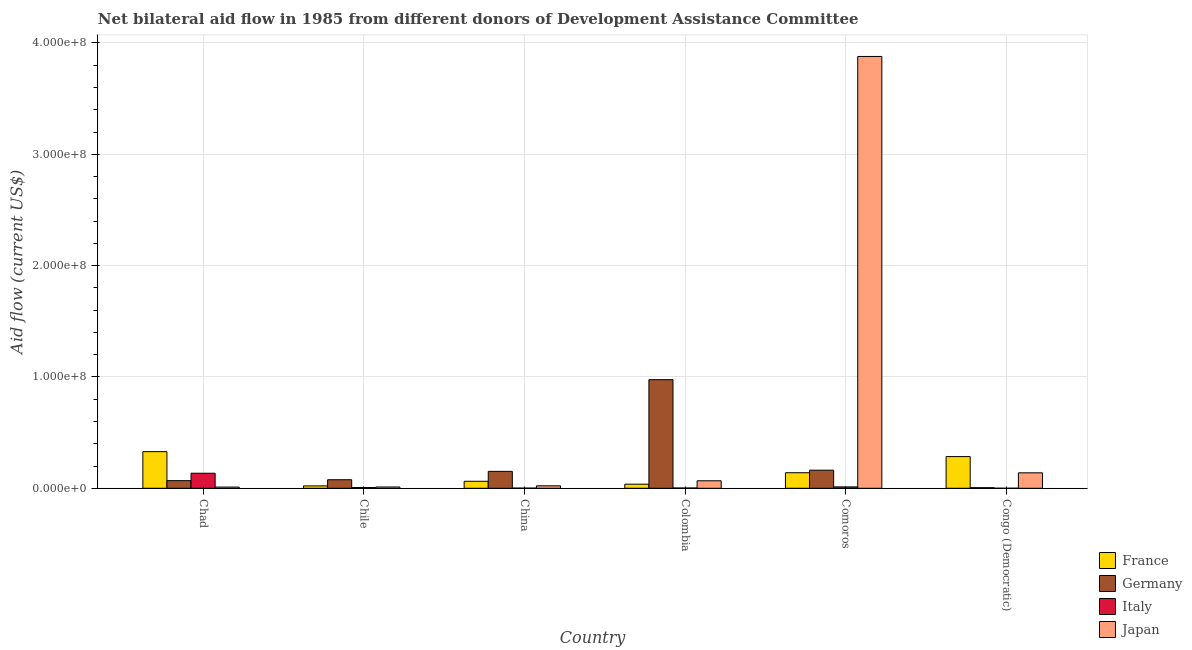How many different coloured bars are there?
Offer a terse response. 4. How many bars are there on the 4th tick from the left?
Make the answer very short. 4. What is the amount of aid given by germany in Chile?
Provide a short and direct response. 7.68e+06. Across all countries, what is the maximum amount of aid given by japan?
Give a very brief answer. 3.88e+08. Across all countries, what is the minimum amount of aid given by france?
Your answer should be very brief. 2.15e+06. In which country was the amount of aid given by italy maximum?
Make the answer very short. Chad. In which country was the amount of aid given by japan minimum?
Make the answer very short. Chad. What is the total amount of aid given by france in the graph?
Your answer should be very brief. 8.75e+07. What is the difference between the amount of aid given by germany in Chile and that in China?
Provide a succinct answer. -7.52e+06. What is the difference between the amount of aid given by japan in Chad and the amount of aid given by germany in Congo (Democratic)?
Keep it short and to the point. 5.40e+05. What is the average amount of aid given by germany per country?
Provide a succinct answer. 2.40e+07. What is the difference between the amount of aid given by france and amount of aid given by germany in China?
Your response must be concise. -8.90e+06. In how many countries, is the amount of aid given by germany greater than 220000000 US$?
Offer a very short reply. 0. What is the ratio of the amount of aid given by japan in Colombia to that in Congo (Democratic)?
Your answer should be very brief. 0.48. Is the amount of aid given by germany in China less than that in Congo (Democratic)?
Your response must be concise. No. What is the difference between the highest and the second highest amount of aid given by japan?
Give a very brief answer. 3.74e+08. What is the difference between the highest and the lowest amount of aid given by france?
Your answer should be very brief. 3.08e+07. What does the 4th bar from the left in Colombia represents?
Keep it short and to the point. Japan. What does the 2nd bar from the right in Chile represents?
Make the answer very short. Italy. Is it the case that in every country, the sum of the amount of aid given by france and amount of aid given by germany is greater than the amount of aid given by italy?
Your answer should be very brief. Yes. How many countries are there in the graph?
Make the answer very short. 6. Are the values on the major ticks of Y-axis written in scientific E-notation?
Your answer should be very brief. Yes. Does the graph contain grids?
Your answer should be very brief. Yes. Where does the legend appear in the graph?
Your answer should be very brief. Bottom right. How are the legend labels stacked?
Make the answer very short. Vertical. What is the title of the graph?
Make the answer very short. Net bilateral aid flow in 1985 from different donors of Development Assistance Committee. What is the Aid flow (current US$) in France in Chad?
Ensure brevity in your answer.  3.29e+07. What is the Aid flow (current US$) of Germany in Chad?
Offer a terse response. 6.84e+06. What is the Aid flow (current US$) of Italy in Chad?
Offer a very short reply. 1.35e+07. What is the Aid flow (current US$) of Japan in Chad?
Keep it short and to the point. 1.07e+06. What is the Aid flow (current US$) of France in Chile?
Offer a very short reply. 2.15e+06. What is the Aid flow (current US$) in Germany in Chile?
Your response must be concise. 7.68e+06. What is the Aid flow (current US$) in Italy in Chile?
Offer a terse response. 6.70e+05. What is the Aid flow (current US$) in Japan in Chile?
Your response must be concise. 1.16e+06. What is the Aid flow (current US$) in France in China?
Your answer should be compact. 6.30e+06. What is the Aid flow (current US$) in Germany in China?
Keep it short and to the point. 1.52e+07. What is the Aid flow (current US$) in Japan in China?
Make the answer very short. 2.21e+06. What is the Aid flow (current US$) in France in Colombia?
Your answer should be compact. 3.68e+06. What is the Aid flow (current US$) in Germany in Colombia?
Keep it short and to the point. 9.76e+07. What is the Aid flow (current US$) of Japan in Colombia?
Ensure brevity in your answer.  6.73e+06. What is the Aid flow (current US$) in France in Comoros?
Keep it short and to the point. 1.40e+07. What is the Aid flow (current US$) of Germany in Comoros?
Give a very brief answer. 1.62e+07. What is the Aid flow (current US$) in Italy in Comoros?
Ensure brevity in your answer.  1.24e+06. What is the Aid flow (current US$) of Japan in Comoros?
Your answer should be very brief. 3.88e+08. What is the Aid flow (current US$) in France in Congo (Democratic)?
Provide a short and direct response. 2.85e+07. What is the Aid flow (current US$) of Germany in Congo (Democratic)?
Offer a very short reply. 5.30e+05. What is the Aid flow (current US$) of Italy in Congo (Democratic)?
Your answer should be very brief. 4.00e+04. What is the Aid flow (current US$) of Japan in Congo (Democratic)?
Keep it short and to the point. 1.39e+07. Across all countries, what is the maximum Aid flow (current US$) of France?
Make the answer very short. 3.29e+07. Across all countries, what is the maximum Aid flow (current US$) of Germany?
Your answer should be compact. 9.76e+07. Across all countries, what is the maximum Aid flow (current US$) in Italy?
Make the answer very short. 1.35e+07. Across all countries, what is the maximum Aid flow (current US$) in Japan?
Provide a short and direct response. 3.88e+08. Across all countries, what is the minimum Aid flow (current US$) in France?
Provide a short and direct response. 2.15e+06. Across all countries, what is the minimum Aid flow (current US$) in Germany?
Offer a terse response. 5.30e+05. Across all countries, what is the minimum Aid flow (current US$) in Italy?
Offer a very short reply. 4.00e+04. Across all countries, what is the minimum Aid flow (current US$) of Japan?
Give a very brief answer. 1.07e+06. What is the total Aid flow (current US$) in France in the graph?
Make the answer very short. 8.75e+07. What is the total Aid flow (current US$) in Germany in the graph?
Provide a short and direct response. 1.44e+08. What is the total Aid flow (current US$) in Italy in the graph?
Offer a terse response. 1.59e+07. What is the total Aid flow (current US$) of Japan in the graph?
Provide a short and direct response. 4.13e+08. What is the difference between the Aid flow (current US$) in France in Chad and that in Chile?
Your answer should be very brief. 3.08e+07. What is the difference between the Aid flow (current US$) of Germany in Chad and that in Chile?
Offer a terse response. -8.40e+05. What is the difference between the Aid flow (current US$) of Italy in Chad and that in Chile?
Ensure brevity in your answer.  1.28e+07. What is the difference between the Aid flow (current US$) of Japan in Chad and that in Chile?
Your answer should be very brief. -9.00e+04. What is the difference between the Aid flow (current US$) in France in Chad and that in China?
Keep it short and to the point. 2.66e+07. What is the difference between the Aid flow (current US$) in Germany in Chad and that in China?
Your response must be concise. -8.36e+06. What is the difference between the Aid flow (current US$) of Italy in Chad and that in China?
Offer a terse response. 1.34e+07. What is the difference between the Aid flow (current US$) in Japan in Chad and that in China?
Your response must be concise. -1.14e+06. What is the difference between the Aid flow (current US$) in France in Chad and that in Colombia?
Your answer should be very brief. 2.92e+07. What is the difference between the Aid flow (current US$) of Germany in Chad and that in Colombia?
Provide a succinct answer. -9.07e+07. What is the difference between the Aid flow (current US$) in Italy in Chad and that in Colombia?
Your answer should be very brief. 1.32e+07. What is the difference between the Aid flow (current US$) in Japan in Chad and that in Colombia?
Keep it short and to the point. -5.66e+06. What is the difference between the Aid flow (current US$) in France in Chad and that in Comoros?
Offer a very short reply. 1.89e+07. What is the difference between the Aid flow (current US$) of Germany in Chad and that in Comoros?
Your answer should be compact. -9.40e+06. What is the difference between the Aid flow (current US$) of Italy in Chad and that in Comoros?
Make the answer very short. 1.23e+07. What is the difference between the Aid flow (current US$) of Japan in Chad and that in Comoros?
Your answer should be compact. -3.87e+08. What is the difference between the Aid flow (current US$) in France in Chad and that in Congo (Democratic)?
Make the answer very short. 4.43e+06. What is the difference between the Aid flow (current US$) of Germany in Chad and that in Congo (Democratic)?
Your answer should be very brief. 6.31e+06. What is the difference between the Aid flow (current US$) in Italy in Chad and that in Congo (Democratic)?
Provide a succinct answer. 1.35e+07. What is the difference between the Aid flow (current US$) of Japan in Chad and that in Congo (Democratic)?
Give a very brief answer. -1.28e+07. What is the difference between the Aid flow (current US$) of France in Chile and that in China?
Your answer should be very brief. -4.15e+06. What is the difference between the Aid flow (current US$) in Germany in Chile and that in China?
Your answer should be compact. -7.52e+06. What is the difference between the Aid flow (current US$) in Italy in Chile and that in China?
Your response must be concise. 5.30e+05. What is the difference between the Aid flow (current US$) in Japan in Chile and that in China?
Offer a very short reply. -1.05e+06. What is the difference between the Aid flow (current US$) of France in Chile and that in Colombia?
Provide a succinct answer. -1.53e+06. What is the difference between the Aid flow (current US$) of Germany in Chile and that in Colombia?
Provide a short and direct response. -8.99e+07. What is the difference between the Aid flow (current US$) of Japan in Chile and that in Colombia?
Offer a very short reply. -5.57e+06. What is the difference between the Aid flow (current US$) of France in Chile and that in Comoros?
Provide a succinct answer. -1.18e+07. What is the difference between the Aid flow (current US$) of Germany in Chile and that in Comoros?
Provide a succinct answer. -8.56e+06. What is the difference between the Aid flow (current US$) in Italy in Chile and that in Comoros?
Your answer should be compact. -5.70e+05. What is the difference between the Aid flow (current US$) in Japan in Chile and that in Comoros?
Your answer should be compact. -3.87e+08. What is the difference between the Aid flow (current US$) in France in Chile and that in Congo (Democratic)?
Your response must be concise. -2.63e+07. What is the difference between the Aid flow (current US$) in Germany in Chile and that in Congo (Democratic)?
Provide a succinct answer. 7.15e+06. What is the difference between the Aid flow (current US$) of Italy in Chile and that in Congo (Democratic)?
Offer a very short reply. 6.30e+05. What is the difference between the Aid flow (current US$) in Japan in Chile and that in Congo (Democratic)?
Your answer should be very brief. -1.27e+07. What is the difference between the Aid flow (current US$) in France in China and that in Colombia?
Provide a succinct answer. 2.62e+06. What is the difference between the Aid flow (current US$) of Germany in China and that in Colombia?
Offer a very short reply. -8.24e+07. What is the difference between the Aid flow (current US$) of Japan in China and that in Colombia?
Keep it short and to the point. -4.52e+06. What is the difference between the Aid flow (current US$) in France in China and that in Comoros?
Provide a short and direct response. -7.67e+06. What is the difference between the Aid flow (current US$) of Germany in China and that in Comoros?
Offer a very short reply. -1.04e+06. What is the difference between the Aid flow (current US$) of Italy in China and that in Comoros?
Make the answer very short. -1.10e+06. What is the difference between the Aid flow (current US$) of Japan in China and that in Comoros?
Offer a very short reply. -3.86e+08. What is the difference between the Aid flow (current US$) in France in China and that in Congo (Democratic)?
Offer a terse response. -2.22e+07. What is the difference between the Aid flow (current US$) of Germany in China and that in Congo (Democratic)?
Provide a short and direct response. 1.47e+07. What is the difference between the Aid flow (current US$) in Japan in China and that in Congo (Democratic)?
Provide a succinct answer. -1.17e+07. What is the difference between the Aid flow (current US$) of France in Colombia and that in Comoros?
Keep it short and to the point. -1.03e+07. What is the difference between the Aid flow (current US$) in Germany in Colombia and that in Comoros?
Your answer should be compact. 8.13e+07. What is the difference between the Aid flow (current US$) in Italy in Colombia and that in Comoros?
Your answer should be very brief. -9.80e+05. What is the difference between the Aid flow (current US$) of Japan in Colombia and that in Comoros?
Make the answer very short. -3.81e+08. What is the difference between the Aid flow (current US$) of France in Colombia and that in Congo (Democratic)?
Ensure brevity in your answer.  -2.48e+07. What is the difference between the Aid flow (current US$) of Germany in Colombia and that in Congo (Democratic)?
Ensure brevity in your answer.  9.70e+07. What is the difference between the Aid flow (current US$) of Italy in Colombia and that in Congo (Democratic)?
Offer a terse response. 2.20e+05. What is the difference between the Aid flow (current US$) in Japan in Colombia and that in Congo (Democratic)?
Your response must be concise. -7.16e+06. What is the difference between the Aid flow (current US$) in France in Comoros and that in Congo (Democratic)?
Your answer should be very brief. -1.45e+07. What is the difference between the Aid flow (current US$) of Germany in Comoros and that in Congo (Democratic)?
Give a very brief answer. 1.57e+07. What is the difference between the Aid flow (current US$) of Italy in Comoros and that in Congo (Democratic)?
Ensure brevity in your answer.  1.20e+06. What is the difference between the Aid flow (current US$) of Japan in Comoros and that in Congo (Democratic)?
Give a very brief answer. 3.74e+08. What is the difference between the Aid flow (current US$) in France in Chad and the Aid flow (current US$) in Germany in Chile?
Provide a short and direct response. 2.52e+07. What is the difference between the Aid flow (current US$) in France in Chad and the Aid flow (current US$) in Italy in Chile?
Give a very brief answer. 3.22e+07. What is the difference between the Aid flow (current US$) of France in Chad and the Aid flow (current US$) of Japan in Chile?
Your response must be concise. 3.17e+07. What is the difference between the Aid flow (current US$) of Germany in Chad and the Aid flow (current US$) of Italy in Chile?
Ensure brevity in your answer.  6.17e+06. What is the difference between the Aid flow (current US$) of Germany in Chad and the Aid flow (current US$) of Japan in Chile?
Provide a short and direct response. 5.68e+06. What is the difference between the Aid flow (current US$) of Italy in Chad and the Aid flow (current US$) of Japan in Chile?
Your answer should be very brief. 1.24e+07. What is the difference between the Aid flow (current US$) of France in Chad and the Aid flow (current US$) of Germany in China?
Provide a succinct answer. 1.77e+07. What is the difference between the Aid flow (current US$) in France in Chad and the Aid flow (current US$) in Italy in China?
Make the answer very short. 3.28e+07. What is the difference between the Aid flow (current US$) in France in Chad and the Aid flow (current US$) in Japan in China?
Give a very brief answer. 3.07e+07. What is the difference between the Aid flow (current US$) of Germany in Chad and the Aid flow (current US$) of Italy in China?
Offer a very short reply. 6.70e+06. What is the difference between the Aid flow (current US$) in Germany in Chad and the Aid flow (current US$) in Japan in China?
Ensure brevity in your answer.  4.63e+06. What is the difference between the Aid flow (current US$) of Italy in Chad and the Aid flow (current US$) of Japan in China?
Keep it short and to the point. 1.13e+07. What is the difference between the Aid flow (current US$) in France in Chad and the Aid flow (current US$) in Germany in Colombia?
Offer a terse response. -6.47e+07. What is the difference between the Aid flow (current US$) in France in Chad and the Aid flow (current US$) in Italy in Colombia?
Make the answer very short. 3.26e+07. What is the difference between the Aid flow (current US$) of France in Chad and the Aid flow (current US$) of Japan in Colombia?
Your answer should be very brief. 2.62e+07. What is the difference between the Aid flow (current US$) of Germany in Chad and the Aid flow (current US$) of Italy in Colombia?
Provide a succinct answer. 6.58e+06. What is the difference between the Aid flow (current US$) in Germany in Chad and the Aid flow (current US$) in Japan in Colombia?
Provide a short and direct response. 1.10e+05. What is the difference between the Aid flow (current US$) in Italy in Chad and the Aid flow (current US$) in Japan in Colombia?
Your answer should be compact. 6.78e+06. What is the difference between the Aid flow (current US$) of France in Chad and the Aid flow (current US$) of Germany in Comoros?
Provide a succinct answer. 1.67e+07. What is the difference between the Aid flow (current US$) in France in Chad and the Aid flow (current US$) in Italy in Comoros?
Your answer should be very brief. 3.17e+07. What is the difference between the Aid flow (current US$) of France in Chad and the Aid flow (current US$) of Japan in Comoros?
Keep it short and to the point. -3.55e+08. What is the difference between the Aid flow (current US$) of Germany in Chad and the Aid flow (current US$) of Italy in Comoros?
Your answer should be very brief. 5.60e+06. What is the difference between the Aid flow (current US$) of Germany in Chad and the Aid flow (current US$) of Japan in Comoros?
Provide a succinct answer. -3.81e+08. What is the difference between the Aid flow (current US$) of Italy in Chad and the Aid flow (current US$) of Japan in Comoros?
Make the answer very short. -3.74e+08. What is the difference between the Aid flow (current US$) in France in Chad and the Aid flow (current US$) in Germany in Congo (Democratic)?
Keep it short and to the point. 3.24e+07. What is the difference between the Aid flow (current US$) of France in Chad and the Aid flow (current US$) of Italy in Congo (Democratic)?
Your answer should be compact. 3.29e+07. What is the difference between the Aid flow (current US$) of France in Chad and the Aid flow (current US$) of Japan in Congo (Democratic)?
Offer a terse response. 1.90e+07. What is the difference between the Aid flow (current US$) of Germany in Chad and the Aid flow (current US$) of Italy in Congo (Democratic)?
Ensure brevity in your answer.  6.80e+06. What is the difference between the Aid flow (current US$) of Germany in Chad and the Aid flow (current US$) of Japan in Congo (Democratic)?
Ensure brevity in your answer.  -7.05e+06. What is the difference between the Aid flow (current US$) of Italy in Chad and the Aid flow (current US$) of Japan in Congo (Democratic)?
Make the answer very short. -3.80e+05. What is the difference between the Aid flow (current US$) in France in Chile and the Aid flow (current US$) in Germany in China?
Give a very brief answer. -1.30e+07. What is the difference between the Aid flow (current US$) of France in Chile and the Aid flow (current US$) of Italy in China?
Offer a very short reply. 2.01e+06. What is the difference between the Aid flow (current US$) in Germany in Chile and the Aid flow (current US$) in Italy in China?
Keep it short and to the point. 7.54e+06. What is the difference between the Aid flow (current US$) of Germany in Chile and the Aid flow (current US$) of Japan in China?
Give a very brief answer. 5.47e+06. What is the difference between the Aid flow (current US$) in Italy in Chile and the Aid flow (current US$) in Japan in China?
Provide a succinct answer. -1.54e+06. What is the difference between the Aid flow (current US$) of France in Chile and the Aid flow (current US$) of Germany in Colombia?
Make the answer very short. -9.54e+07. What is the difference between the Aid flow (current US$) of France in Chile and the Aid flow (current US$) of Italy in Colombia?
Provide a succinct answer. 1.89e+06. What is the difference between the Aid flow (current US$) in France in Chile and the Aid flow (current US$) in Japan in Colombia?
Make the answer very short. -4.58e+06. What is the difference between the Aid flow (current US$) in Germany in Chile and the Aid flow (current US$) in Italy in Colombia?
Keep it short and to the point. 7.42e+06. What is the difference between the Aid flow (current US$) in Germany in Chile and the Aid flow (current US$) in Japan in Colombia?
Make the answer very short. 9.50e+05. What is the difference between the Aid flow (current US$) in Italy in Chile and the Aid flow (current US$) in Japan in Colombia?
Make the answer very short. -6.06e+06. What is the difference between the Aid flow (current US$) of France in Chile and the Aid flow (current US$) of Germany in Comoros?
Offer a very short reply. -1.41e+07. What is the difference between the Aid flow (current US$) in France in Chile and the Aid flow (current US$) in Italy in Comoros?
Provide a short and direct response. 9.10e+05. What is the difference between the Aid flow (current US$) in France in Chile and the Aid flow (current US$) in Japan in Comoros?
Your answer should be very brief. -3.86e+08. What is the difference between the Aid flow (current US$) in Germany in Chile and the Aid flow (current US$) in Italy in Comoros?
Provide a succinct answer. 6.44e+06. What is the difference between the Aid flow (current US$) in Germany in Chile and the Aid flow (current US$) in Japan in Comoros?
Your answer should be compact. -3.80e+08. What is the difference between the Aid flow (current US$) in Italy in Chile and the Aid flow (current US$) in Japan in Comoros?
Make the answer very short. -3.87e+08. What is the difference between the Aid flow (current US$) of France in Chile and the Aid flow (current US$) of Germany in Congo (Democratic)?
Your answer should be compact. 1.62e+06. What is the difference between the Aid flow (current US$) of France in Chile and the Aid flow (current US$) of Italy in Congo (Democratic)?
Keep it short and to the point. 2.11e+06. What is the difference between the Aid flow (current US$) in France in Chile and the Aid flow (current US$) in Japan in Congo (Democratic)?
Keep it short and to the point. -1.17e+07. What is the difference between the Aid flow (current US$) in Germany in Chile and the Aid flow (current US$) in Italy in Congo (Democratic)?
Give a very brief answer. 7.64e+06. What is the difference between the Aid flow (current US$) in Germany in Chile and the Aid flow (current US$) in Japan in Congo (Democratic)?
Provide a succinct answer. -6.21e+06. What is the difference between the Aid flow (current US$) in Italy in Chile and the Aid flow (current US$) in Japan in Congo (Democratic)?
Offer a terse response. -1.32e+07. What is the difference between the Aid flow (current US$) of France in China and the Aid flow (current US$) of Germany in Colombia?
Your answer should be very brief. -9.13e+07. What is the difference between the Aid flow (current US$) of France in China and the Aid flow (current US$) of Italy in Colombia?
Provide a short and direct response. 6.04e+06. What is the difference between the Aid flow (current US$) in France in China and the Aid flow (current US$) in Japan in Colombia?
Your answer should be very brief. -4.30e+05. What is the difference between the Aid flow (current US$) of Germany in China and the Aid flow (current US$) of Italy in Colombia?
Give a very brief answer. 1.49e+07. What is the difference between the Aid flow (current US$) of Germany in China and the Aid flow (current US$) of Japan in Colombia?
Make the answer very short. 8.47e+06. What is the difference between the Aid flow (current US$) in Italy in China and the Aid flow (current US$) in Japan in Colombia?
Give a very brief answer. -6.59e+06. What is the difference between the Aid flow (current US$) in France in China and the Aid flow (current US$) in Germany in Comoros?
Your response must be concise. -9.94e+06. What is the difference between the Aid flow (current US$) in France in China and the Aid flow (current US$) in Italy in Comoros?
Offer a terse response. 5.06e+06. What is the difference between the Aid flow (current US$) of France in China and the Aid flow (current US$) of Japan in Comoros?
Offer a terse response. -3.82e+08. What is the difference between the Aid flow (current US$) in Germany in China and the Aid flow (current US$) in Italy in Comoros?
Your answer should be very brief. 1.40e+07. What is the difference between the Aid flow (current US$) in Germany in China and the Aid flow (current US$) in Japan in Comoros?
Keep it short and to the point. -3.73e+08. What is the difference between the Aid flow (current US$) of Italy in China and the Aid flow (current US$) of Japan in Comoros?
Provide a succinct answer. -3.88e+08. What is the difference between the Aid flow (current US$) of France in China and the Aid flow (current US$) of Germany in Congo (Democratic)?
Your response must be concise. 5.77e+06. What is the difference between the Aid flow (current US$) of France in China and the Aid flow (current US$) of Italy in Congo (Democratic)?
Provide a short and direct response. 6.26e+06. What is the difference between the Aid flow (current US$) of France in China and the Aid flow (current US$) of Japan in Congo (Democratic)?
Your answer should be very brief. -7.59e+06. What is the difference between the Aid flow (current US$) of Germany in China and the Aid flow (current US$) of Italy in Congo (Democratic)?
Ensure brevity in your answer.  1.52e+07. What is the difference between the Aid flow (current US$) of Germany in China and the Aid flow (current US$) of Japan in Congo (Democratic)?
Offer a terse response. 1.31e+06. What is the difference between the Aid flow (current US$) of Italy in China and the Aid flow (current US$) of Japan in Congo (Democratic)?
Provide a succinct answer. -1.38e+07. What is the difference between the Aid flow (current US$) in France in Colombia and the Aid flow (current US$) in Germany in Comoros?
Provide a short and direct response. -1.26e+07. What is the difference between the Aid flow (current US$) of France in Colombia and the Aid flow (current US$) of Italy in Comoros?
Provide a succinct answer. 2.44e+06. What is the difference between the Aid flow (current US$) of France in Colombia and the Aid flow (current US$) of Japan in Comoros?
Your answer should be compact. -3.84e+08. What is the difference between the Aid flow (current US$) of Germany in Colombia and the Aid flow (current US$) of Italy in Comoros?
Provide a succinct answer. 9.63e+07. What is the difference between the Aid flow (current US$) of Germany in Colombia and the Aid flow (current US$) of Japan in Comoros?
Your answer should be compact. -2.90e+08. What is the difference between the Aid flow (current US$) in Italy in Colombia and the Aid flow (current US$) in Japan in Comoros?
Make the answer very short. -3.88e+08. What is the difference between the Aid flow (current US$) of France in Colombia and the Aid flow (current US$) of Germany in Congo (Democratic)?
Your answer should be very brief. 3.15e+06. What is the difference between the Aid flow (current US$) of France in Colombia and the Aid flow (current US$) of Italy in Congo (Democratic)?
Provide a short and direct response. 3.64e+06. What is the difference between the Aid flow (current US$) in France in Colombia and the Aid flow (current US$) in Japan in Congo (Democratic)?
Your answer should be very brief. -1.02e+07. What is the difference between the Aid flow (current US$) in Germany in Colombia and the Aid flow (current US$) in Italy in Congo (Democratic)?
Give a very brief answer. 9.75e+07. What is the difference between the Aid flow (current US$) of Germany in Colombia and the Aid flow (current US$) of Japan in Congo (Democratic)?
Your answer should be compact. 8.37e+07. What is the difference between the Aid flow (current US$) in Italy in Colombia and the Aid flow (current US$) in Japan in Congo (Democratic)?
Provide a short and direct response. -1.36e+07. What is the difference between the Aid flow (current US$) in France in Comoros and the Aid flow (current US$) in Germany in Congo (Democratic)?
Provide a succinct answer. 1.34e+07. What is the difference between the Aid flow (current US$) in France in Comoros and the Aid flow (current US$) in Italy in Congo (Democratic)?
Your response must be concise. 1.39e+07. What is the difference between the Aid flow (current US$) in France in Comoros and the Aid flow (current US$) in Japan in Congo (Democratic)?
Offer a very short reply. 8.00e+04. What is the difference between the Aid flow (current US$) in Germany in Comoros and the Aid flow (current US$) in Italy in Congo (Democratic)?
Ensure brevity in your answer.  1.62e+07. What is the difference between the Aid flow (current US$) in Germany in Comoros and the Aid flow (current US$) in Japan in Congo (Democratic)?
Ensure brevity in your answer.  2.35e+06. What is the difference between the Aid flow (current US$) in Italy in Comoros and the Aid flow (current US$) in Japan in Congo (Democratic)?
Make the answer very short. -1.26e+07. What is the average Aid flow (current US$) of France per country?
Provide a succinct answer. 1.46e+07. What is the average Aid flow (current US$) in Germany per country?
Make the answer very short. 2.40e+07. What is the average Aid flow (current US$) in Italy per country?
Provide a succinct answer. 2.64e+06. What is the average Aid flow (current US$) in Japan per country?
Your answer should be very brief. 6.88e+07. What is the difference between the Aid flow (current US$) in France and Aid flow (current US$) in Germany in Chad?
Offer a very short reply. 2.61e+07. What is the difference between the Aid flow (current US$) of France and Aid flow (current US$) of Italy in Chad?
Your response must be concise. 1.94e+07. What is the difference between the Aid flow (current US$) of France and Aid flow (current US$) of Japan in Chad?
Ensure brevity in your answer.  3.18e+07. What is the difference between the Aid flow (current US$) in Germany and Aid flow (current US$) in Italy in Chad?
Make the answer very short. -6.67e+06. What is the difference between the Aid flow (current US$) of Germany and Aid flow (current US$) of Japan in Chad?
Keep it short and to the point. 5.77e+06. What is the difference between the Aid flow (current US$) of Italy and Aid flow (current US$) of Japan in Chad?
Give a very brief answer. 1.24e+07. What is the difference between the Aid flow (current US$) in France and Aid flow (current US$) in Germany in Chile?
Give a very brief answer. -5.53e+06. What is the difference between the Aid flow (current US$) in France and Aid flow (current US$) in Italy in Chile?
Provide a short and direct response. 1.48e+06. What is the difference between the Aid flow (current US$) of France and Aid flow (current US$) of Japan in Chile?
Offer a terse response. 9.90e+05. What is the difference between the Aid flow (current US$) in Germany and Aid flow (current US$) in Italy in Chile?
Ensure brevity in your answer.  7.01e+06. What is the difference between the Aid flow (current US$) in Germany and Aid flow (current US$) in Japan in Chile?
Offer a very short reply. 6.52e+06. What is the difference between the Aid flow (current US$) of Italy and Aid flow (current US$) of Japan in Chile?
Provide a short and direct response. -4.90e+05. What is the difference between the Aid flow (current US$) in France and Aid flow (current US$) in Germany in China?
Give a very brief answer. -8.90e+06. What is the difference between the Aid flow (current US$) in France and Aid flow (current US$) in Italy in China?
Your answer should be very brief. 6.16e+06. What is the difference between the Aid flow (current US$) of France and Aid flow (current US$) of Japan in China?
Offer a very short reply. 4.09e+06. What is the difference between the Aid flow (current US$) of Germany and Aid flow (current US$) of Italy in China?
Offer a very short reply. 1.51e+07. What is the difference between the Aid flow (current US$) of Germany and Aid flow (current US$) of Japan in China?
Make the answer very short. 1.30e+07. What is the difference between the Aid flow (current US$) in Italy and Aid flow (current US$) in Japan in China?
Keep it short and to the point. -2.07e+06. What is the difference between the Aid flow (current US$) in France and Aid flow (current US$) in Germany in Colombia?
Your answer should be very brief. -9.39e+07. What is the difference between the Aid flow (current US$) in France and Aid flow (current US$) in Italy in Colombia?
Offer a very short reply. 3.42e+06. What is the difference between the Aid flow (current US$) of France and Aid flow (current US$) of Japan in Colombia?
Give a very brief answer. -3.05e+06. What is the difference between the Aid flow (current US$) in Germany and Aid flow (current US$) in Italy in Colombia?
Provide a succinct answer. 9.73e+07. What is the difference between the Aid flow (current US$) of Germany and Aid flow (current US$) of Japan in Colombia?
Provide a short and direct response. 9.08e+07. What is the difference between the Aid flow (current US$) of Italy and Aid flow (current US$) of Japan in Colombia?
Your answer should be very brief. -6.47e+06. What is the difference between the Aid flow (current US$) of France and Aid flow (current US$) of Germany in Comoros?
Give a very brief answer. -2.27e+06. What is the difference between the Aid flow (current US$) of France and Aid flow (current US$) of Italy in Comoros?
Your response must be concise. 1.27e+07. What is the difference between the Aid flow (current US$) in France and Aid flow (current US$) in Japan in Comoros?
Your answer should be very brief. -3.74e+08. What is the difference between the Aid flow (current US$) of Germany and Aid flow (current US$) of Italy in Comoros?
Offer a very short reply. 1.50e+07. What is the difference between the Aid flow (current US$) of Germany and Aid flow (current US$) of Japan in Comoros?
Provide a short and direct response. -3.72e+08. What is the difference between the Aid flow (current US$) of Italy and Aid flow (current US$) of Japan in Comoros?
Keep it short and to the point. -3.87e+08. What is the difference between the Aid flow (current US$) in France and Aid flow (current US$) in Germany in Congo (Democratic)?
Provide a short and direct response. 2.79e+07. What is the difference between the Aid flow (current US$) of France and Aid flow (current US$) of Italy in Congo (Democratic)?
Provide a short and direct response. 2.84e+07. What is the difference between the Aid flow (current US$) of France and Aid flow (current US$) of Japan in Congo (Democratic)?
Your response must be concise. 1.46e+07. What is the difference between the Aid flow (current US$) of Germany and Aid flow (current US$) of Italy in Congo (Democratic)?
Your response must be concise. 4.90e+05. What is the difference between the Aid flow (current US$) of Germany and Aid flow (current US$) of Japan in Congo (Democratic)?
Provide a succinct answer. -1.34e+07. What is the difference between the Aid flow (current US$) of Italy and Aid flow (current US$) of Japan in Congo (Democratic)?
Make the answer very short. -1.38e+07. What is the ratio of the Aid flow (current US$) in France in Chad to that in Chile?
Give a very brief answer. 15.3. What is the ratio of the Aid flow (current US$) of Germany in Chad to that in Chile?
Your response must be concise. 0.89. What is the ratio of the Aid flow (current US$) of Italy in Chad to that in Chile?
Make the answer very short. 20.16. What is the ratio of the Aid flow (current US$) in Japan in Chad to that in Chile?
Offer a terse response. 0.92. What is the ratio of the Aid flow (current US$) of France in Chad to that in China?
Offer a very short reply. 5.22. What is the ratio of the Aid flow (current US$) of Germany in Chad to that in China?
Provide a short and direct response. 0.45. What is the ratio of the Aid flow (current US$) of Italy in Chad to that in China?
Keep it short and to the point. 96.5. What is the ratio of the Aid flow (current US$) in Japan in Chad to that in China?
Ensure brevity in your answer.  0.48. What is the ratio of the Aid flow (current US$) in France in Chad to that in Colombia?
Your response must be concise. 8.94. What is the ratio of the Aid flow (current US$) in Germany in Chad to that in Colombia?
Offer a terse response. 0.07. What is the ratio of the Aid flow (current US$) of Italy in Chad to that in Colombia?
Your response must be concise. 51.96. What is the ratio of the Aid flow (current US$) of Japan in Chad to that in Colombia?
Make the answer very short. 0.16. What is the ratio of the Aid flow (current US$) in France in Chad to that in Comoros?
Your answer should be compact. 2.35. What is the ratio of the Aid flow (current US$) in Germany in Chad to that in Comoros?
Offer a very short reply. 0.42. What is the ratio of the Aid flow (current US$) in Italy in Chad to that in Comoros?
Your answer should be very brief. 10.9. What is the ratio of the Aid flow (current US$) in Japan in Chad to that in Comoros?
Keep it short and to the point. 0. What is the ratio of the Aid flow (current US$) of France in Chad to that in Congo (Democratic)?
Provide a succinct answer. 1.16. What is the ratio of the Aid flow (current US$) in Germany in Chad to that in Congo (Democratic)?
Offer a terse response. 12.91. What is the ratio of the Aid flow (current US$) in Italy in Chad to that in Congo (Democratic)?
Your answer should be compact. 337.75. What is the ratio of the Aid flow (current US$) of Japan in Chad to that in Congo (Democratic)?
Your response must be concise. 0.08. What is the ratio of the Aid flow (current US$) in France in Chile to that in China?
Your answer should be very brief. 0.34. What is the ratio of the Aid flow (current US$) of Germany in Chile to that in China?
Offer a terse response. 0.51. What is the ratio of the Aid flow (current US$) of Italy in Chile to that in China?
Make the answer very short. 4.79. What is the ratio of the Aid flow (current US$) in Japan in Chile to that in China?
Offer a terse response. 0.52. What is the ratio of the Aid flow (current US$) of France in Chile to that in Colombia?
Give a very brief answer. 0.58. What is the ratio of the Aid flow (current US$) of Germany in Chile to that in Colombia?
Your response must be concise. 0.08. What is the ratio of the Aid flow (current US$) of Italy in Chile to that in Colombia?
Offer a terse response. 2.58. What is the ratio of the Aid flow (current US$) of Japan in Chile to that in Colombia?
Offer a terse response. 0.17. What is the ratio of the Aid flow (current US$) in France in Chile to that in Comoros?
Offer a very short reply. 0.15. What is the ratio of the Aid flow (current US$) of Germany in Chile to that in Comoros?
Keep it short and to the point. 0.47. What is the ratio of the Aid flow (current US$) in Italy in Chile to that in Comoros?
Offer a very short reply. 0.54. What is the ratio of the Aid flow (current US$) of Japan in Chile to that in Comoros?
Your response must be concise. 0. What is the ratio of the Aid flow (current US$) of France in Chile to that in Congo (Democratic)?
Your answer should be very brief. 0.08. What is the ratio of the Aid flow (current US$) in Germany in Chile to that in Congo (Democratic)?
Keep it short and to the point. 14.49. What is the ratio of the Aid flow (current US$) in Italy in Chile to that in Congo (Democratic)?
Your answer should be very brief. 16.75. What is the ratio of the Aid flow (current US$) of Japan in Chile to that in Congo (Democratic)?
Provide a succinct answer. 0.08. What is the ratio of the Aid flow (current US$) in France in China to that in Colombia?
Ensure brevity in your answer.  1.71. What is the ratio of the Aid flow (current US$) of Germany in China to that in Colombia?
Give a very brief answer. 0.16. What is the ratio of the Aid flow (current US$) in Italy in China to that in Colombia?
Make the answer very short. 0.54. What is the ratio of the Aid flow (current US$) in Japan in China to that in Colombia?
Your response must be concise. 0.33. What is the ratio of the Aid flow (current US$) of France in China to that in Comoros?
Provide a succinct answer. 0.45. What is the ratio of the Aid flow (current US$) in Germany in China to that in Comoros?
Your answer should be compact. 0.94. What is the ratio of the Aid flow (current US$) of Italy in China to that in Comoros?
Your answer should be compact. 0.11. What is the ratio of the Aid flow (current US$) of Japan in China to that in Comoros?
Your response must be concise. 0.01. What is the ratio of the Aid flow (current US$) of France in China to that in Congo (Democratic)?
Give a very brief answer. 0.22. What is the ratio of the Aid flow (current US$) of Germany in China to that in Congo (Democratic)?
Offer a very short reply. 28.68. What is the ratio of the Aid flow (current US$) in Japan in China to that in Congo (Democratic)?
Give a very brief answer. 0.16. What is the ratio of the Aid flow (current US$) of France in Colombia to that in Comoros?
Provide a short and direct response. 0.26. What is the ratio of the Aid flow (current US$) in Germany in Colombia to that in Comoros?
Keep it short and to the point. 6.01. What is the ratio of the Aid flow (current US$) in Italy in Colombia to that in Comoros?
Offer a terse response. 0.21. What is the ratio of the Aid flow (current US$) in Japan in Colombia to that in Comoros?
Provide a short and direct response. 0.02. What is the ratio of the Aid flow (current US$) in France in Colombia to that in Congo (Democratic)?
Give a very brief answer. 0.13. What is the ratio of the Aid flow (current US$) in Germany in Colombia to that in Congo (Democratic)?
Ensure brevity in your answer.  184.09. What is the ratio of the Aid flow (current US$) in Italy in Colombia to that in Congo (Democratic)?
Ensure brevity in your answer.  6.5. What is the ratio of the Aid flow (current US$) in Japan in Colombia to that in Congo (Democratic)?
Offer a terse response. 0.48. What is the ratio of the Aid flow (current US$) in France in Comoros to that in Congo (Democratic)?
Offer a terse response. 0.49. What is the ratio of the Aid flow (current US$) of Germany in Comoros to that in Congo (Democratic)?
Give a very brief answer. 30.64. What is the ratio of the Aid flow (current US$) in Japan in Comoros to that in Congo (Democratic)?
Offer a very short reply. 27.93. What is the difference between the highest and the second highest Aid flow (current US$) of France?
Make the answer very short. 4.43e+06. What is the difference between the highest and the second highest Aid flow (current US$) in Germany?
Ensure brevity in your answer.  8.13e+07. What is the difference between the highest and the second highest Aid flow (current US$) in Italy?
Your response must be concise. 1.23e+07. What is the difference between the highest and the second highest Aid flow (current US$) in Japan?
Your answer should be very brief. 3.74e+08. What is the difference between the highest and the lowest Aid flow (current US$) in France?
Keep it short and to the point. 3.08e+07. What is the difference between the highest and the lowest Aid flow (current US$) in Germany?
Your answer should be compact. 9.70e+07. What is the difference between the highest and the lowest Aid flow (current US$) of Italy?
Offer a terse response. 1.35e+07. What is the difference between the highest and the lowest Aid flow (current US$) of Japan?
Keep it short and to the point. 3.87e+08. 